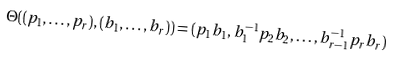<formula> <loc_0><loc_0><loc_500><loc_500>\Theta ( ( p _ { 1 } , \dots , p _ { r } ) , ( b _ { 1 } , \dots , b _ { r } ) ) = ( p _ { 1 } b _ { 1 } , b _ { 1 } ^ { - 1 } p _ { 2 } b _ { 2 } , \dots , b _ { r - 1 } ^ { - 1 } p _ { r } b _ { r } )</formula> 